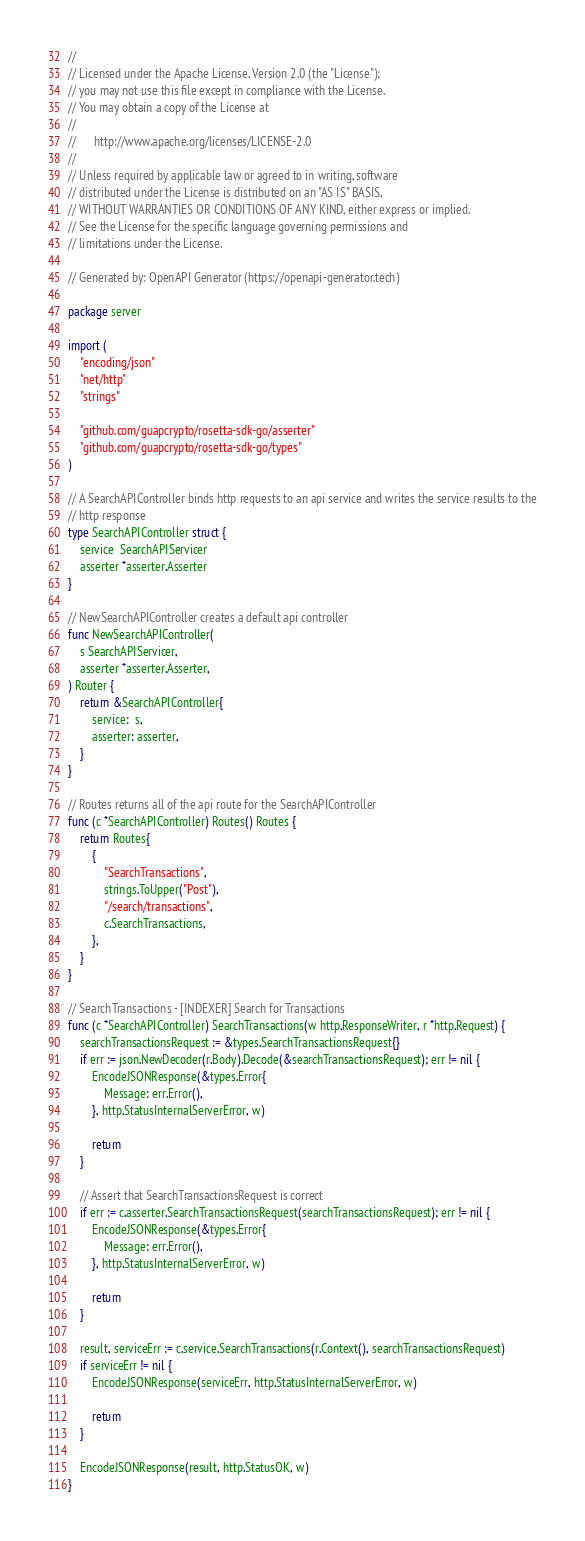Convert code to text. <code><loc_0><loc_0><loc_500><loc_500><_Go_>//
// Licensed under the Apache License, Version 2.0 (the "License");
// you may not use this file except in compliance with the License.
// You may obtain a copy of the License at
//
//      http://www.apache.org/licenses/LICENSE-2.0
//
// Unless required by applicable law or agreed to in writing, software
// distributed under the License is distributed on an "AS IS" BASIS,
// WITHOUT WARRANTIES OR CONDITIONS OF ANY KIND, either express or implied.
// See the License for the specific language governing permissions and
// limitations under the License.

// Generated by: OpenAPI Generator (https://openapi-generator.tech)

package server

import (
	"encoding/json"
	"net/http"
	"strings"

	"github.com/guapcrypto/rosetta-sdk-go/asserter"
	"github.com/guapcrypto/rosetta-sdk-go/types"
)

// A SearchAPIController binds http requests to an api service and writes the service results to the
// http response
type SearchAPIController struct {
	service  SearchAPIServicer
	asserter *asserter.Asserter
}

// NewSearchAPIController creates a default api controller
func NewSearchAPIController(
	s SearchAPIServicer,
	asserter *asserter.Asserter,
) Router {
	return &SearchAPIController{
		service:  s,
		asserter: asserter,
	}
}

// Routes returns all of the api route for the SearchAPIController
func (c *SearchAPIController) Routes() Routes {
	return Routes{
		{
			"SearchTransactions",
			strings.ToUpper("Post"),
			"/search/transactions",
			c.SearchTransactions,
		},
	}
}

// SearchTransactions - [INDEXER] Search for Transactions
func (c *SearchAPIController) SearchTransactions(w http.ResponseWriter, r *http.Request) {
	searchTransactionsRequest := &types.SearchTransactionsRequest{}
	if err := json.NewDecoder(r.Body).Decode(&searchTransactionsRequest); err != nil {
		EncodeJSONResponse(&types.Error{
			Message: err.Error(),
		}, http.StatusInternalServerError, w)

		return
	}

	// Assert that SearchTransactionsRequest is correct
	if err := c.asserter.SearchTransactionsRequest(searchTransactionsRequest); err != nil {
		EncodeJSONResponse(&types.Error{
			Message: err.Error(),
		}, http.StatusInternalServerError, w)

		return
	}

	result, serviceErr := c.service.SearchTransactions(r.Context(), searchTransactionsRequest)
	if serviceErr != nil {
		EncodeJSONResponse(serviceErr, http.StatusInternalServerError, w)

		return
	}

	EncodeJSONResponse(result, http.StatusOK, w)
}
</code> 